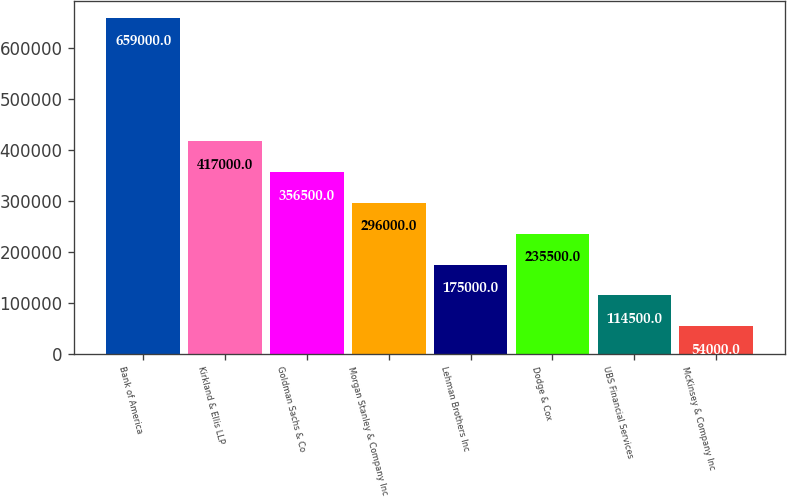Convert chart. <chart><loc_0><loc_0><loc_500><loc_500><bar_chart><fcel>Bank of America<fcel>Kirkland & Ellis LLP<fcel>Goldman Sachs & Co<fcel>Morgan Stanley & Company Inc<fcel>Lehman Brothers Inc<fcel>Dodge & Cox<fcel>UBS Financial Services<fcel>McKinsey & Company Inc<nl><fcel>659000<fcel>417000<fcel>356500<fcel>296000<fcel>175000<fcel>235500<fcel>114500<fcel>54000<nl></chart> 